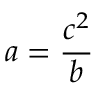Convert formula to latex. <formula><loc_0><loc_0><loc_500><loc_500>a = { \frac { c ^ { 2 } } { b } }</formula> 